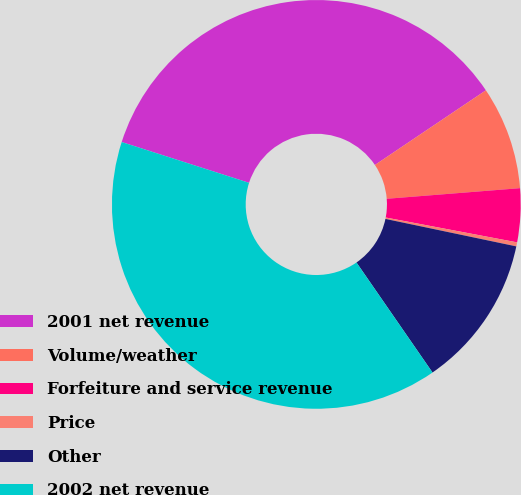Convert chart to OTSL. <chart><loc_0><loc_0><loc_500><loc_500><pie_chart><fcel>2001 net revenue<fcel>Volume/weather<fcel>Forfeiture and service revenue<fcel>Price<fcel>Other<fcel>2002 net revenue<nl><fcel>35.64%<fcel>8.16%<fcel>4.24%<fcel>0.32%<fcel>12.08%<fcel>39.56%<nl></chart> 